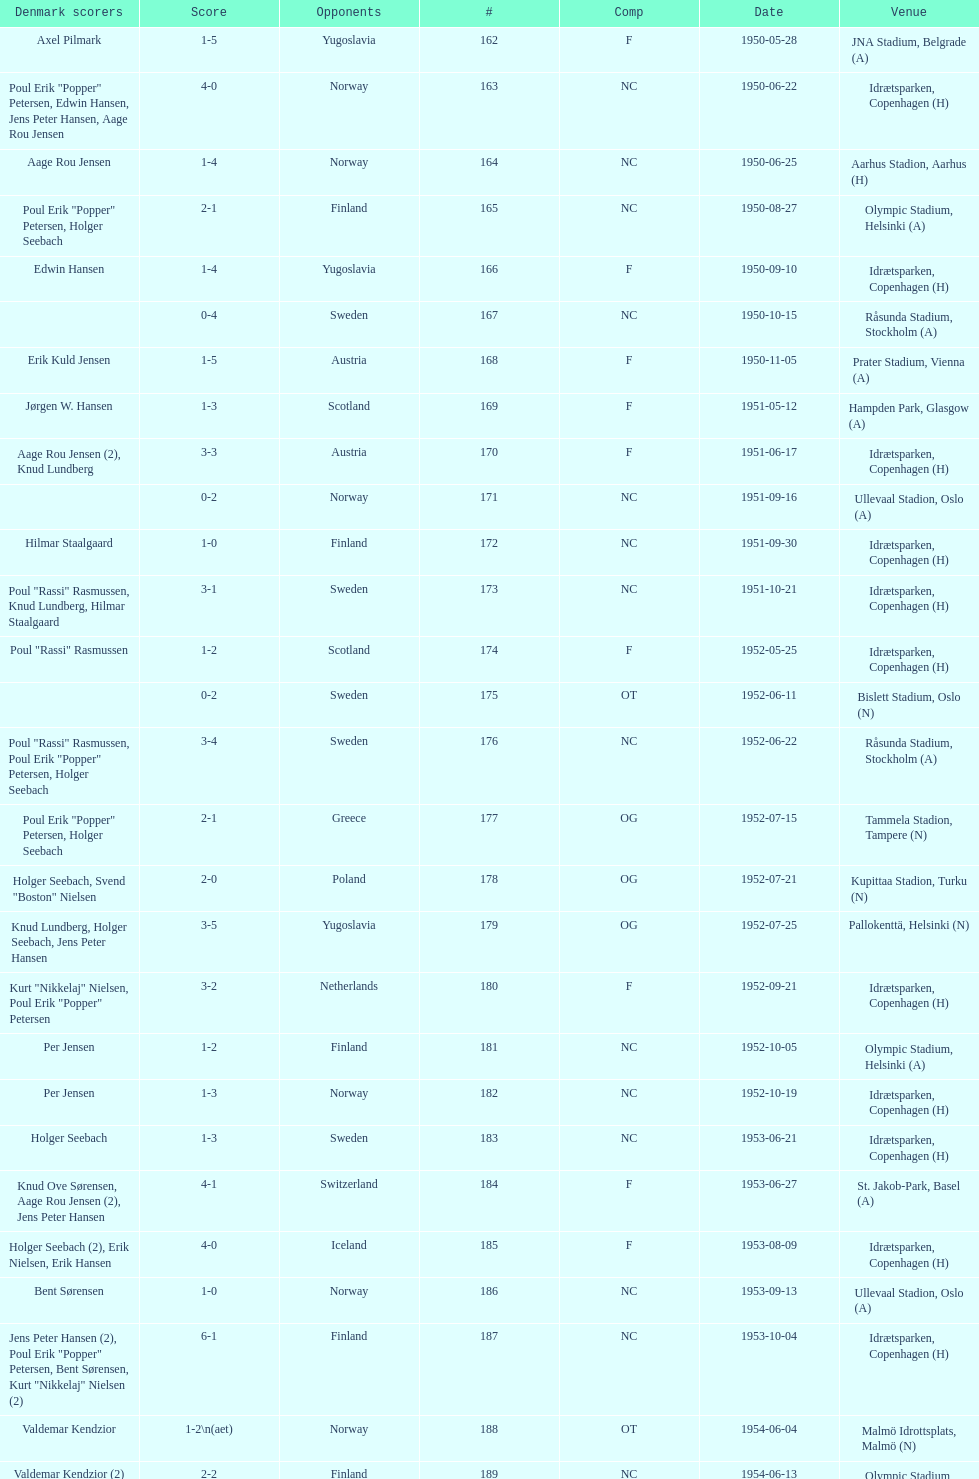In the "comp" column, what is the frequency of "nc" appearances? 32. 